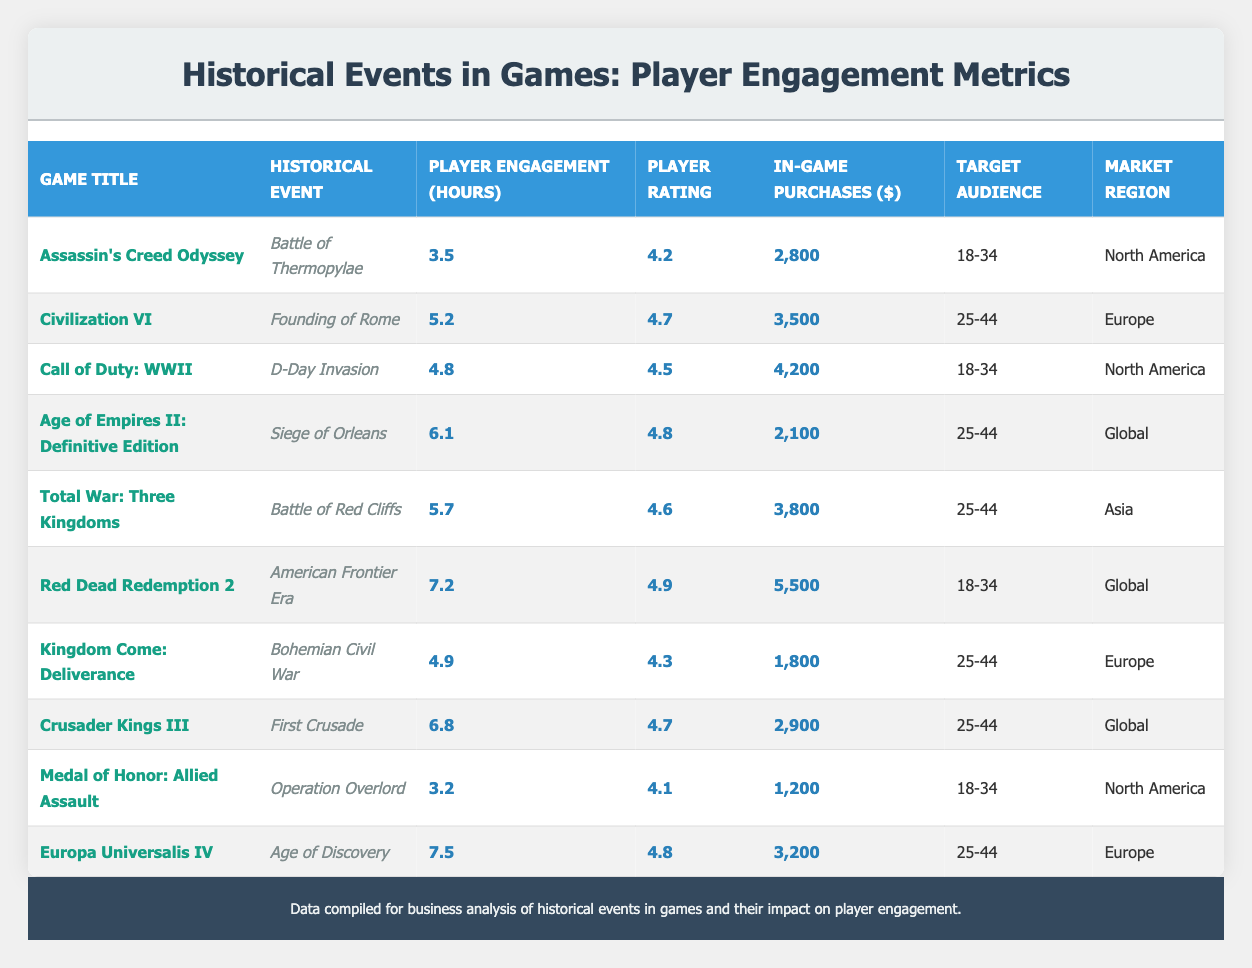What is the player engagement hours for "Red Dead Redemption 2"? The table lists "Red Dead Redemption 2" under the Game Title column. By looking at the corresponding row, the player engagement hours for this game is found in the Player Engagement (hours) column, which is 7.2 hours.
Answer: 7.2 Which historical event has the highest player rating? To identify the highest player rating, I need to compare all values in the Player Rating column. The highest rating is found in the row for "Red Dead Redemption 2," which is 4.9.
Answer: 4.9 How many total in-game purchases were made for games targeting the audience aged 25-44? First, I locate the rows with the target audience "25-44." The in-game purchases for these games are: Civilization VI (3,500), Age of Empires II: Definitive Edition (2,100), Total War: Three Kingdoms (3,800), Kingdom Come: Deliverance (1,800), Crusader Kings III (2,900), and Europa Universalis IV (3,200). Adding these amounts: 3,500 + 2,100 + 3,800 + 1,800 + 2,900 + 3,200 = 17,300.
Answer: 17,300 Is the player engagement hours for "Call of Duty: WWII" greater than that for "Assassin's Creed Odyssey"? The player engagement hours for "Call of Duty: WWII" is 4.8 hours while for "Assassin's Creed Odyssey" it is 3.5 hours. Since 4.8 is greater than 3.5, the answer to the question is yes.
Answer: Yes What is the average player engagement hours for games in the North American region? To find the average, I first identify the games with the market region "North America": Assassin's Creed Odyssey (3.5), Call of Duty: WWII (4.8), and Medal of Honor: Allied Assault (3.2). I sum these: 3.5 + 4.8 + 3.2 = 11.5. There are 3 data points, so the average is 11.5 / 3 = 3.83.
Answer: 3.83 Which game has the lowest in-game purchases and what is the amount? I look through the In-Game Purchases column for the minimum value. The lowest amount is found in the row for "Medal of Honor: Allied Assault," having 1,200.
Answer: 1,200 Does "Total War: Three Kingdoms" have a player engagement hours greater than 5? The player engagement hours for "Total War: Three Kingdoms" is 5.7 hours which is greater than 5. Thus, the answer is yes.
Answer: Yes What is the difference in player engagement hours between the game with the highest and lowest engagement? The game with the highest player engagement hours is "Europa Universalis IV" at 7.5 hours, and the game with the lowest is "Medal of Honor: Allied Assault" at 3.2 hours. The difference is calculated as 7.5 - 3.2 = 4.3.
Answer: 4.3 